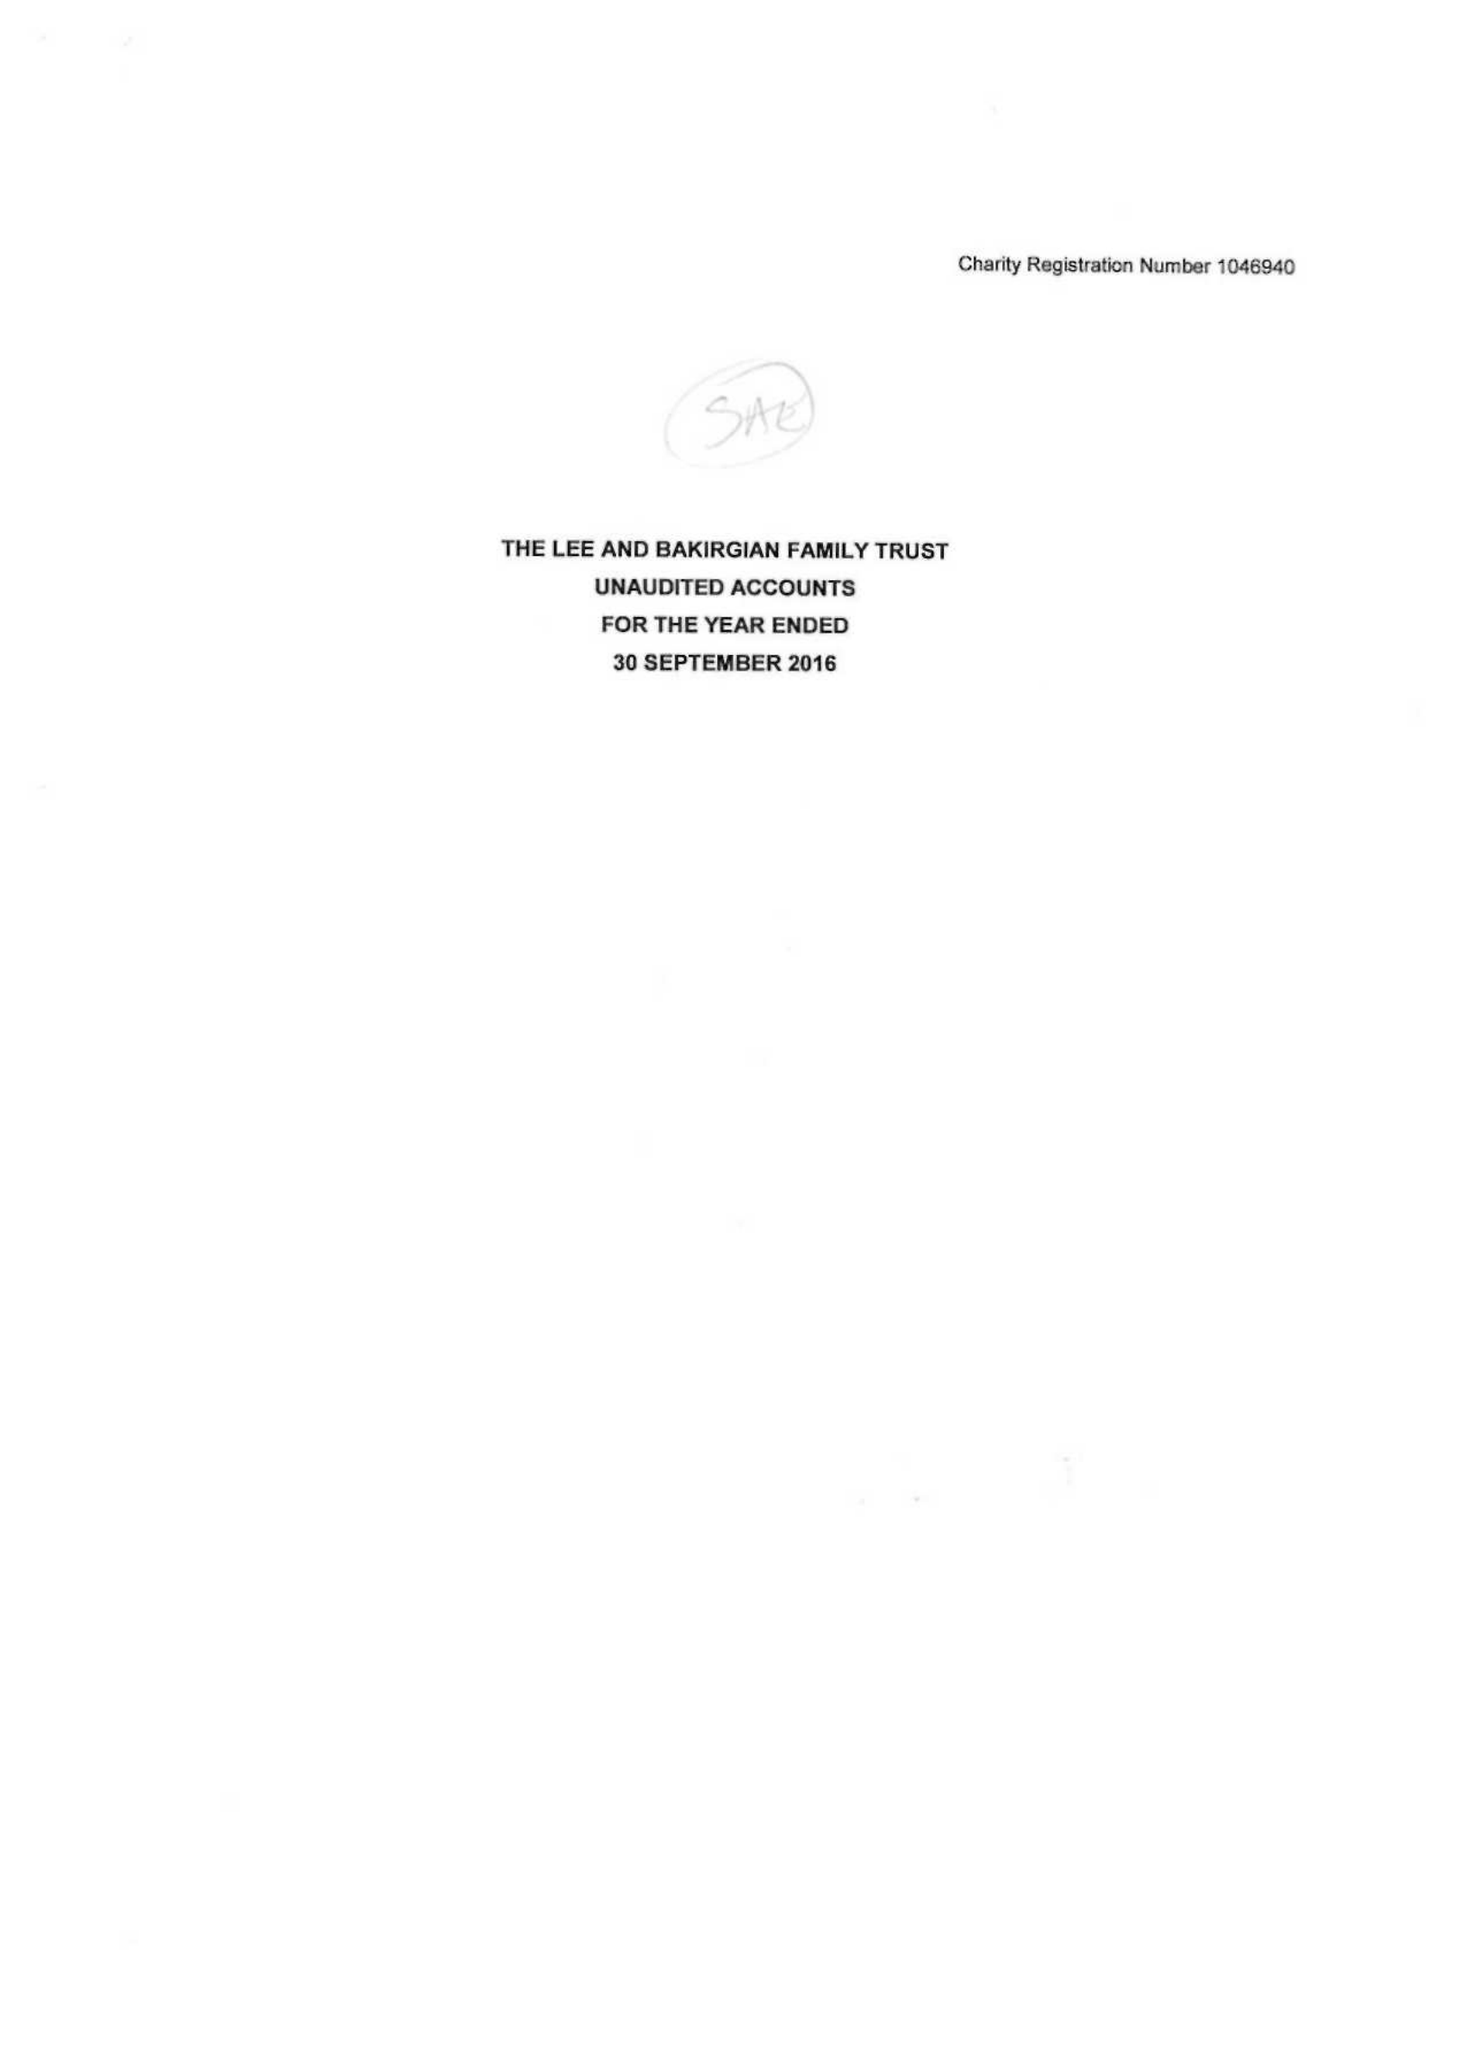What is the value for the charity_name?
Answer the question using a single word or phrase. The Lee and Bakirgian Family Trust 